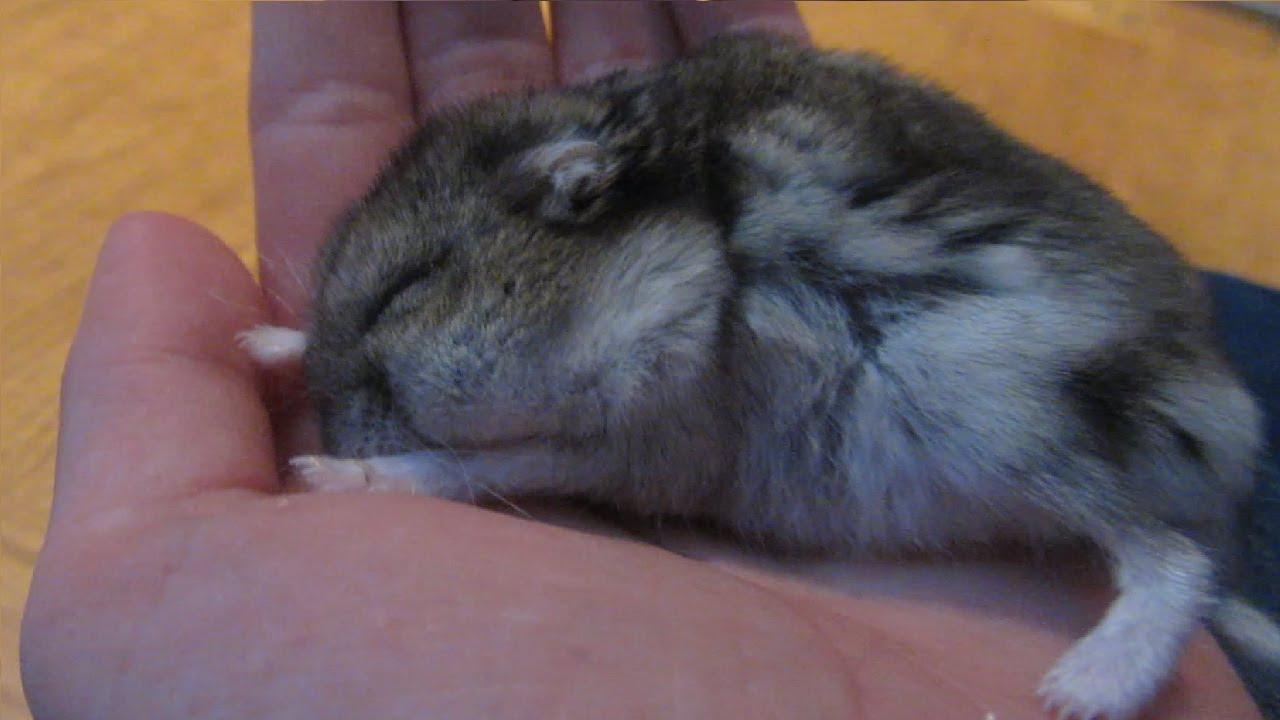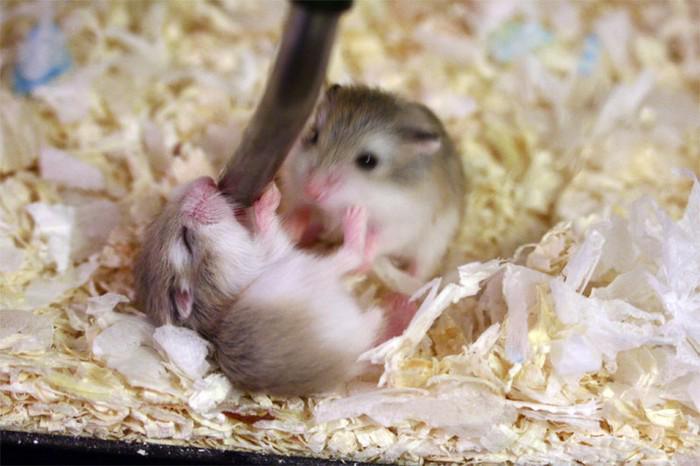The first image is the image on the left, the second image is the image on the right. Considering the images on both sides, is "There is a tiny mammal in a human hand." valid? Answer yes or no. Yes. The first image is the image on the left, the second image is the image on the right. Considering the images on both sides, is "An image shows the white-furred belly of a hamster on its back with all four paws in the air." valid? Answer yes or no. No. 